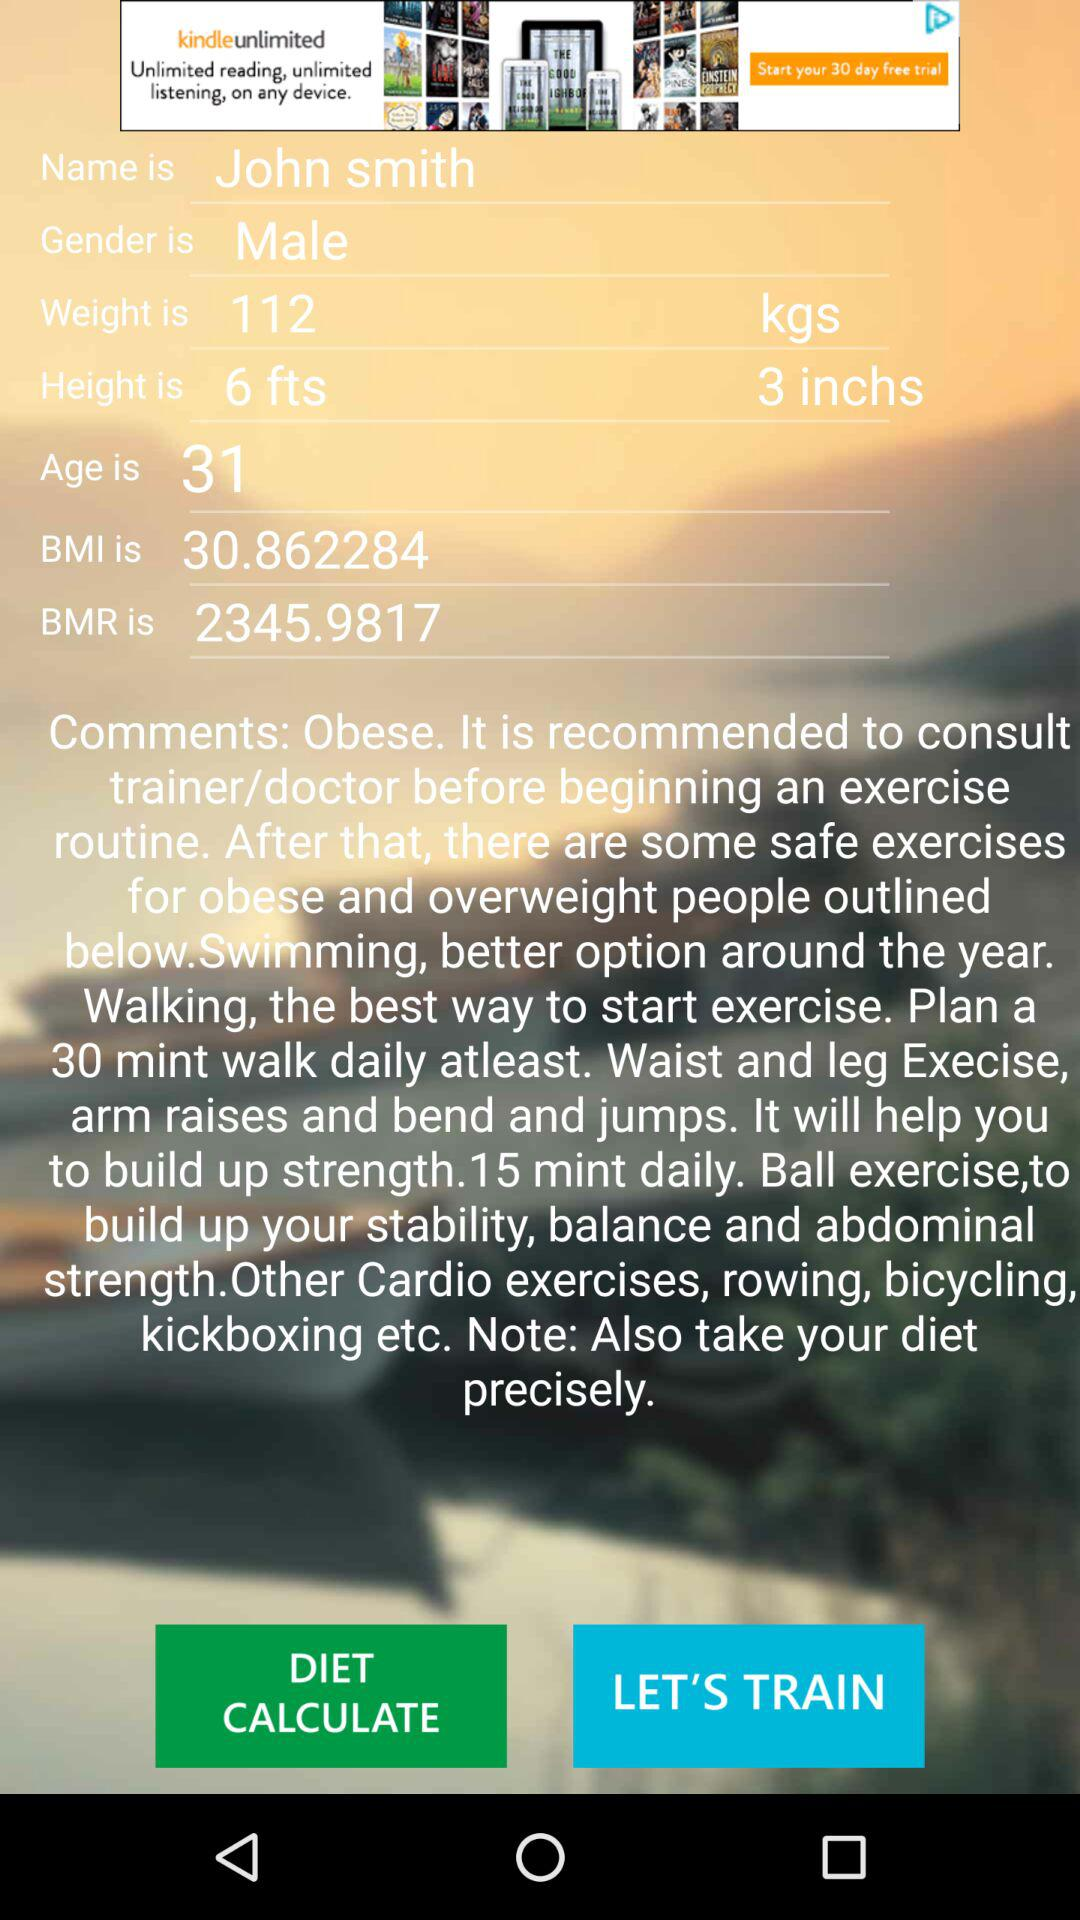What is the BMI? The BMI is 30.862284. 